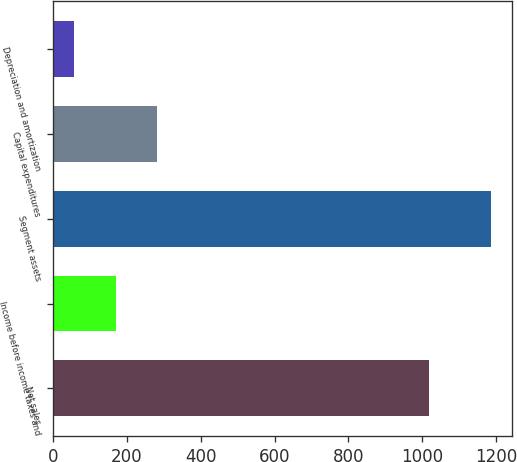<chart> <loc_0><loc_0><loc_500><loc_500><bar_chart><fcel>Net sales<fcel>Income before income taxes and<fcel>Segment assets<fcel>Capital expenditures<fcel>Depreciation and amortization<nl><fcel>1020.1<fcel>169.5<fcel>1185.6<fcel>282.4<fcel>56.6<nl></chart> 